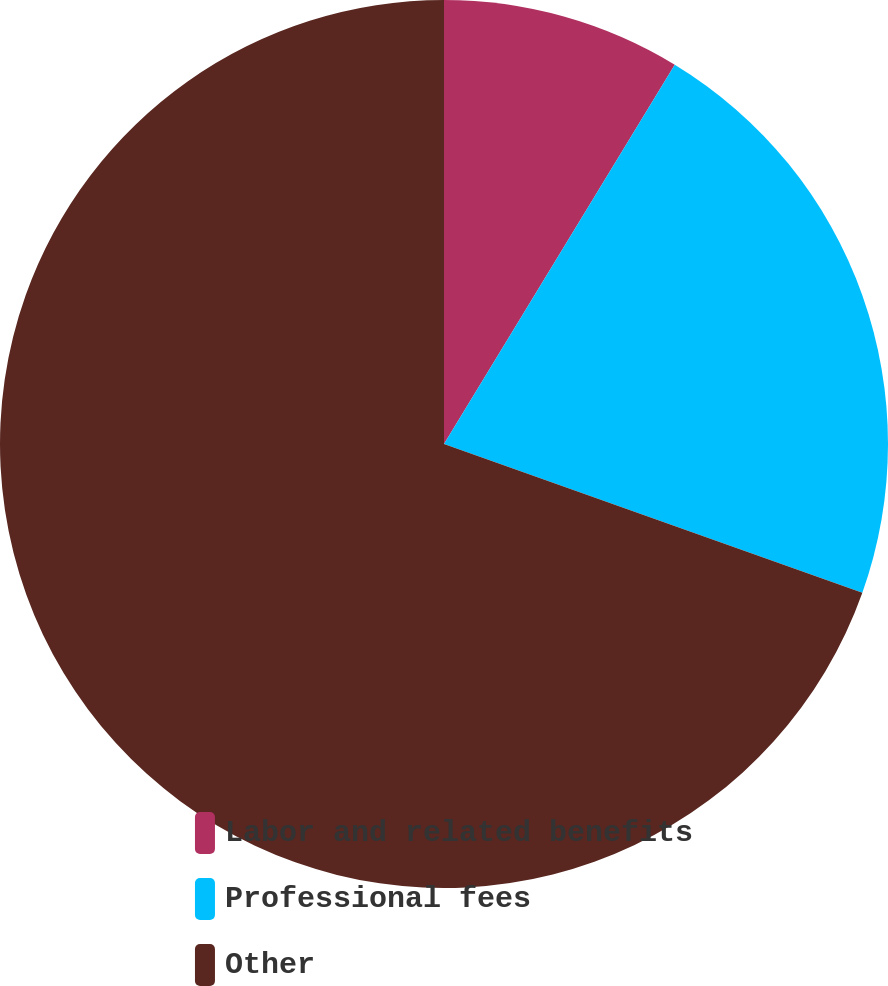Convert chart. <chart><loc_0><loc_0><loc_500><loc_500><pie_chart><fcel>Labor and related benefits<fcel>Professional fees<fcel>Other<nl><fcel>8.7%<fcel>21.74%<fcel>69.57%<nl></chart> 